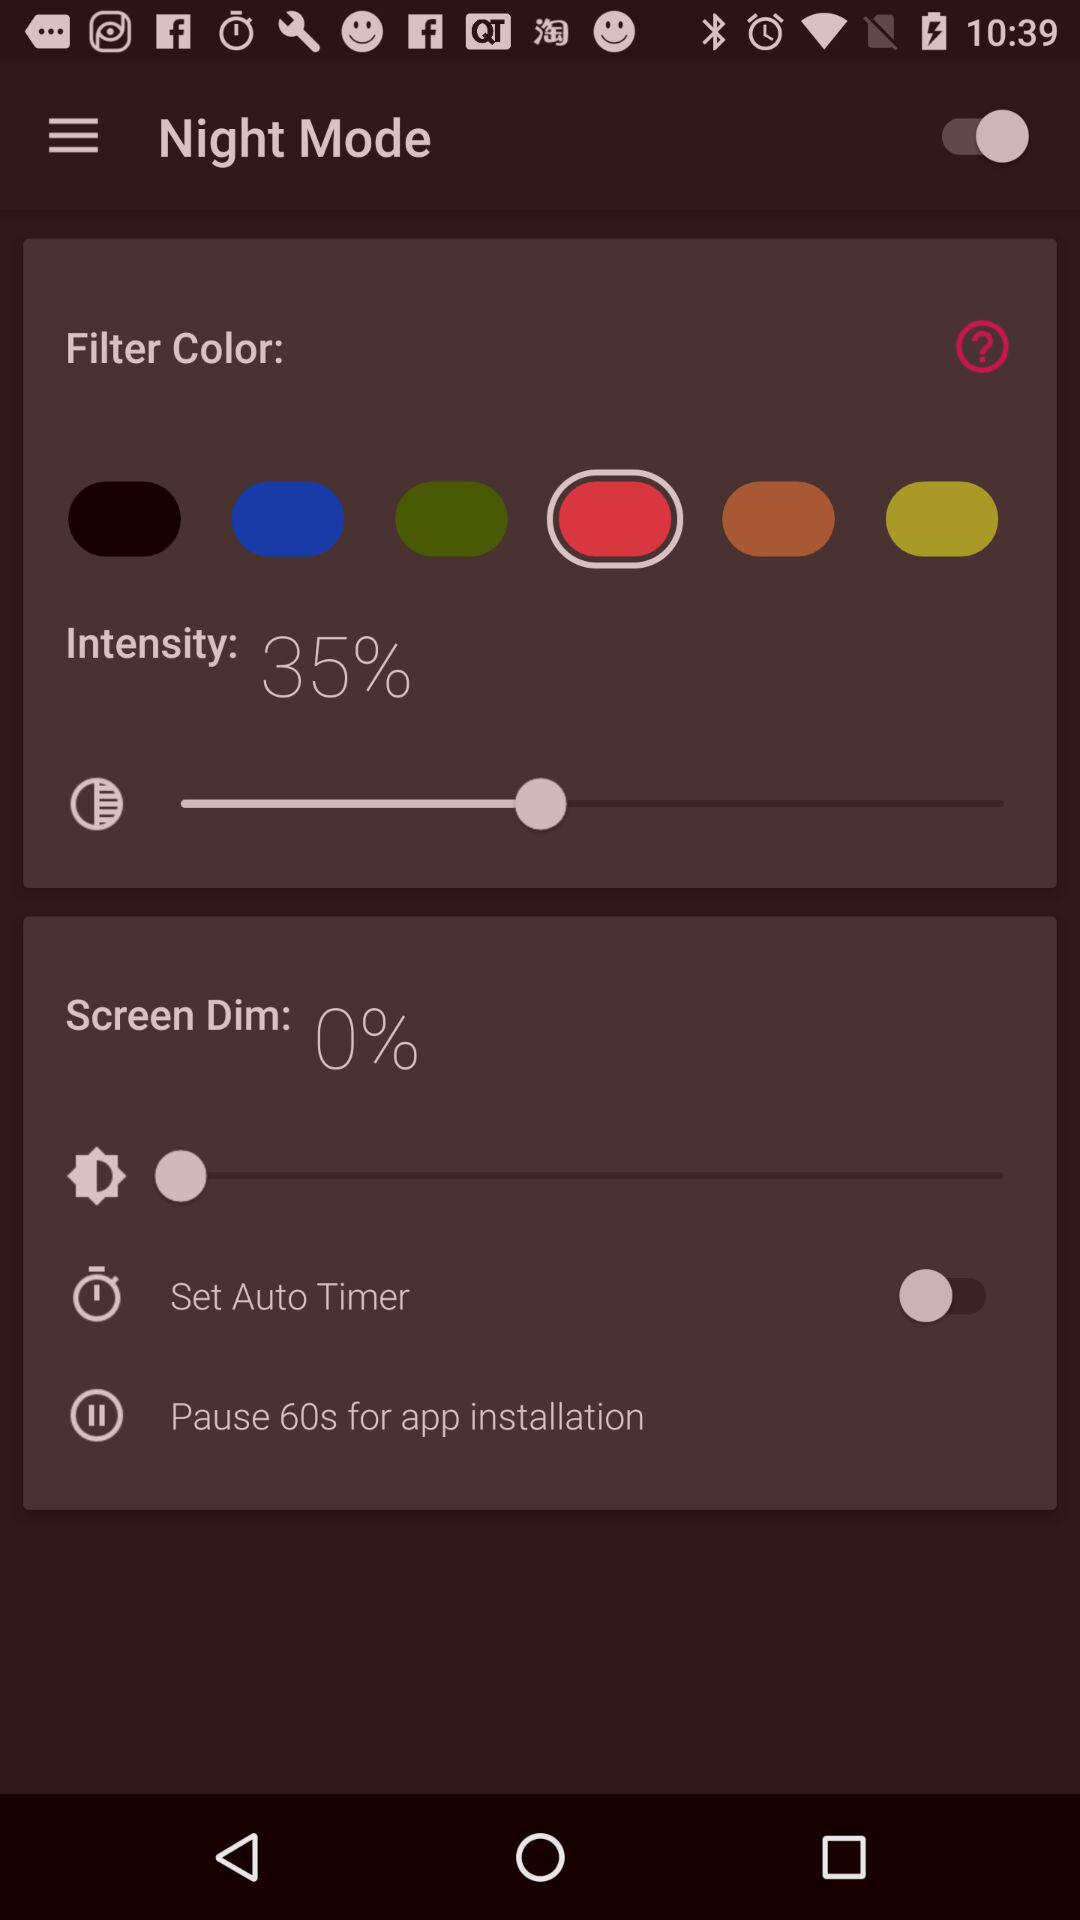For which option is the zero percentage set? The zero percentage is set for the "Screen Dim" option. 